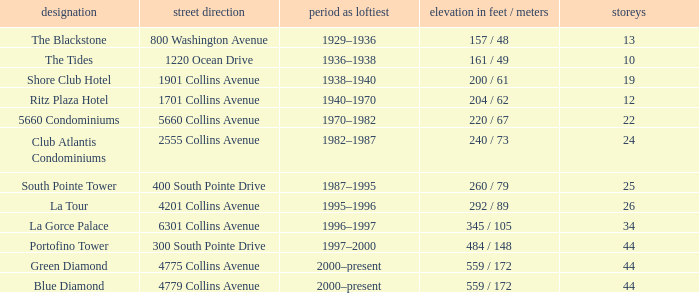How many years was the building with 24 floors the tallest? 1982–1987. 